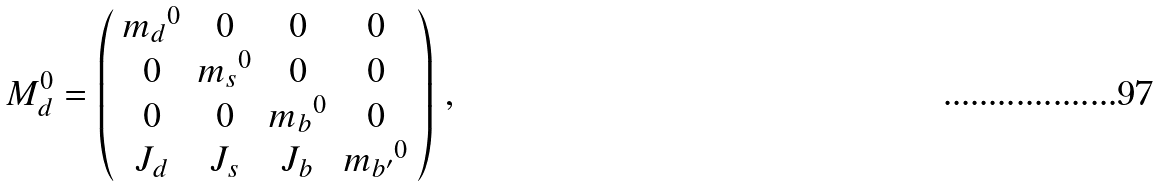Convert formula to latex. <formula><loc_0><loc_0><loc_500><loc_500>M _ { d } ^ { 0 } = \left ( \begin{array} { c c c c } { m _ { d } } ^ { 0 } & 0 & 0 & 0 \\ 0 & { m _ { s } } ^ { 0 } & 0 & 0 \\ 0 & 0 & { m _ { b } } ^ { 0 } & 0 \\ J _ { d } & J _ { s } & J _ { b } & { m _ { b ^ { \prime } } } ^ { 0 } \end{array} \right ) \, ,</formula> 